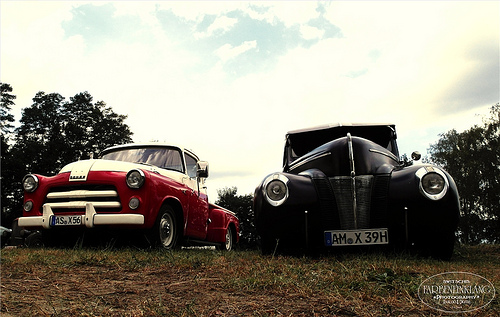<image>
Can you confirm if the car is in front of the car? No. The car is not in front of the car. The spatial positioning shows a different relationship between these objects. 